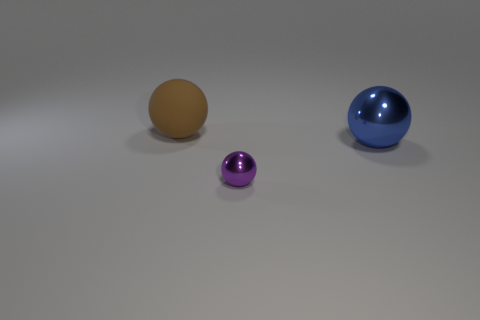Add 2 tiny metallic things. How many objects exist? 5 Subtract all small purple shiny things. Subtract all big brown spheres. How many objects are left? 1 Add 3 tiny purple balls. How many tiny purple balls are left? 4 Add 3 small yellow metal cubes. How many small yellow metal cubes exist? 3 Subtract 0 brown cylinders. How many objects are left? 3 